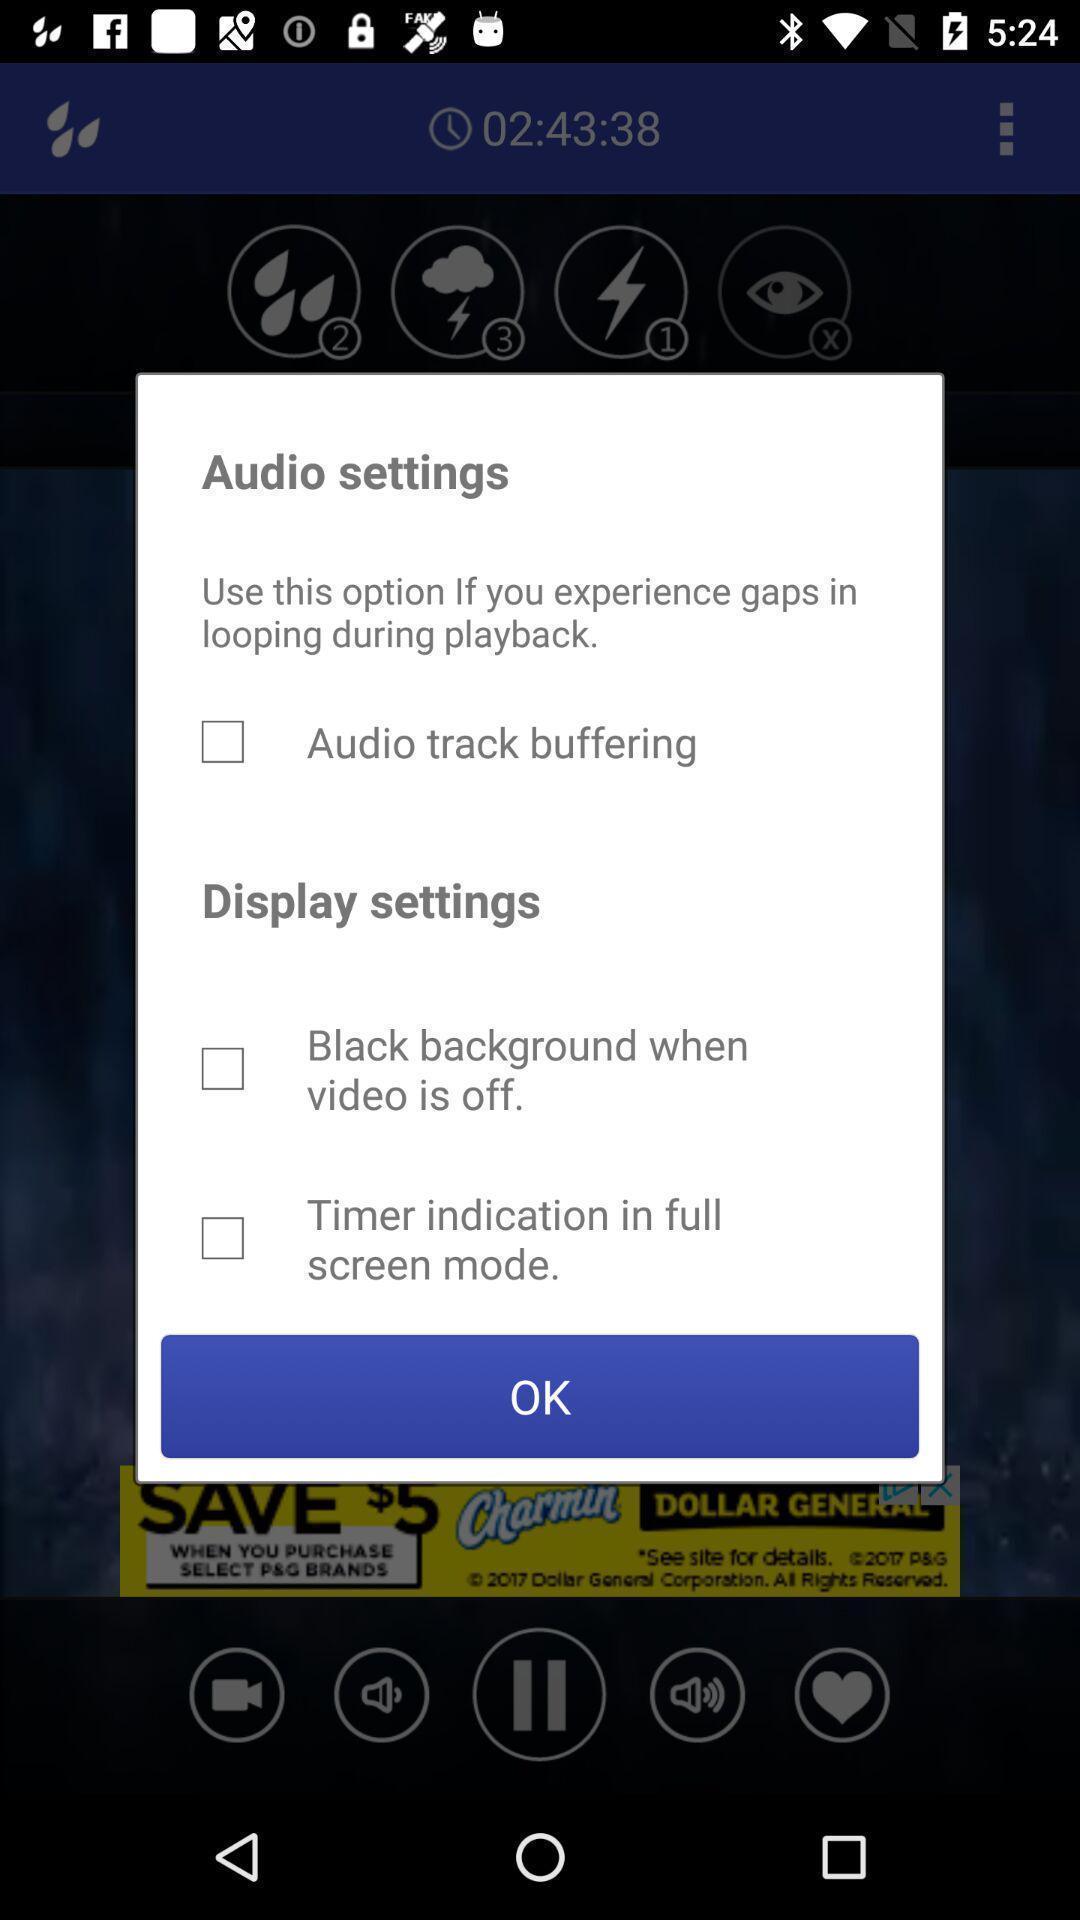Describe the key features of this screenshot. Pop-up displaying audio settings options. 